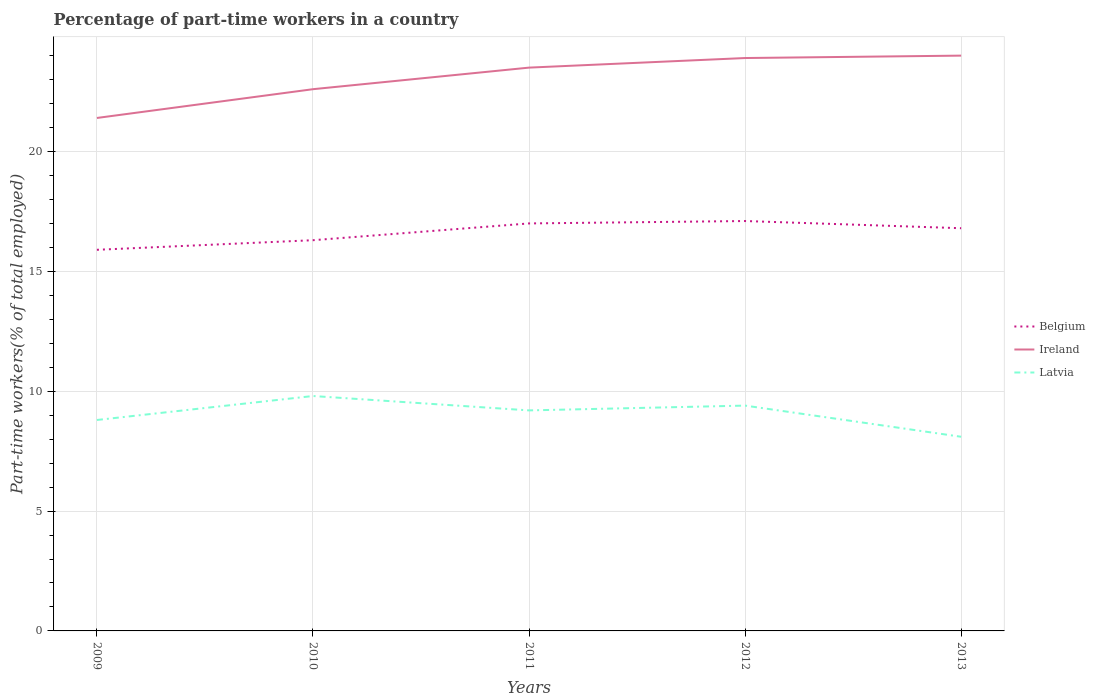Does the line corresponding to Latvia intersect with the line corresponding to Ireland?
Provide a succinct answer. No. Is the number of lines equal to the number of legend labels?
Offer a terse response. Yes. Across all years, what is the maximum percentage of part-time workers in Latvia?
Your response must be concise. 8.1. What is the total percentage of part-time workers in Belgium in the graph?
Offer a very short reply. 0.3. What is the difference between the highest and the second highest percentage of part-time workers in Ireland?
Your answer should be very brief. 2.6. How many lines are there?
Ensure brevity in your answer.  3. Are the values on the major ticks of Y-axis written in scientific E-notation?
Provide a short and direct response. No. Does the graph contain any zero values?
Make the answer very short. No. Does the graph contain grids?
Provide a short and direct response. Yes. Where does the legend appear in the graph?
Give a very brief answer. Center right. How are the legend labels stacked?
Ensure brevity in your answer.  Vertical. What is the title of the graph?
Your answer should be very brief. Percentage of part-time workers in a country. What is the label or title of the X-axis?
Offer a very short reply. Years. What is the label or title of the Y-axis?
Make the answer very short. Part-time workers(% of total employed). What is the Part-time workers(% of total employed) of Belgium in 2009?
Your response must be concise. 15.9. What is the Part-time workers(% of total employed) in Ireland in 2009?
Make the answer very short. 21.4. What is the Part-time workers(% of total employed) in Latvia in 2009?
Your response must be concise. 8.8. What is the Part-time workers(% of total employed) in Belgium in 2010?
Your answer should be compact. 16.3. What is the Part-time workers(% of total employed) in Ireland in 2010?
Give a very brief answer. 22.6. What is the Part-time workers(% of total employed) in Latvia in 2010?
Offer a terse response. 9.8. What is the Part-time workers(% of total employed) in Latvia in 2011?
Provide a succinct answer. 9.2. What is the Part-time workers(% of total employed) of Belgium in 2012?
Your response must be concise. 17.1. What is the Part-time workers(% of total employed) of Ireland in 2012?
Keep it short and to the point. 23.9. What is the Part-time workers(% of total employed) in Latvia in 2012?
Offer a very short reply. 9.4. What is the Part-time workers(% of total employed) of Belgium in 2013?
Your answer should be very brief. 16.8. What is the Part-time workers(% of total employed) in Latvia in 2013?
Offer a very short reply. 8.1. Across all years, what is the maximum Part-time workers(% of total employed) in Belgium?
Provide a short and direct response. 17.1. Across all years, what is the maximum Part-time workers(% of total employed) in Latvia?
Keep it short and to the point. 9.8. Across all years, what is the minimum Part-time workers(% of total employed) in Belgium?
Ensure brevity in your answer.  15.9. Across all years, what is the minimum Part-time workers(% of total employed) of Ireland?
Your answer should be very brief. 21.4. Across all years, what is the minimum Part-time workers(% of total employed) in Latvia?
Give a very brief answer. 8.1. What is the total Part-time workers(% of total employed) of Belgium in the graph?
Make the answer very short. 83.1. What is the total Part-time workers(% of total employed) of Ireland in the graph?
Ensure brevity in your answer.  115.4. What is the total Part-time workers(% of total employed) in Latvia in the graph?
Your answer should be compact. 45.3. What is the difference between the Part-time workers(% of total employed) in Belgium in 2009 and that in 2010?
Your response must be concise. -0.4. What is the difference between the Part-time workers(% of total employed) in Latvia in 2009 and that in 2010?
Your response must be concise. -1. What is the difference between the Part-time workers(% of total employed) of Latvia in 2009 and that in 2011?
Your answer should be compact. -0.4. What is the difference between the Part-time workers(% of total employed) in Latvia in 2009 and that in 2012?
Provide a short and direct response. -0.6. What is the difference between the Part-time workers(% of total employed) in Belgium in 2009 and that in 2013?
Keep it short and to the point. -0.9. What is the difference between the Part-time workers(% of total employed) in Latvia in 2009 and that in 2013?
Keep it short and to the point. 0.7. What is the difference between the Part-time workers(% of total employed) in Belgium in 2010 and that in 2011?
Ensure brevity in your answer.  -0.7. What is the difference between the Part-time workers(% of total employed) in Ireland in 2010 and that in 2011?
Ensure brevity in your answer.  -0.9. What is the difference between the Part-time workers(% of total employed) in Latvia in 2010 and that in 2011?
Your answer should be compact. 0.6. What is the difference between the Part-time workers(% of total employed) of Latvia in 2010 and that in 2012?
Ensure brevity in your answer.  0.4. What is the difference between the Part-time workers(% of total employed) in Latvia in 2010 and that in 2013?
Give a very brief answer. 1.7. What is the difference between the Part-time workers(% of total employed) of Belgium in 2011 and that in 2012?
Keep it short and to the point. -0.1. What is the difference between the Part-time workers(% of total employed) of Belgium in 2011 and that in 2013?
Your answer should be very brief. 0.2. What is the difference between the Part-time workers(% of total employed) of Ireland in 2011 and that in 2013?
Offer a terse response. -0.5. What is the difference between the Part-time workers(% of total employed) in Belgium in 2012 and that in 2013?
Offer a very short reply. 0.3. What is the difference between the Part-time workers(% of total employed) in Ireland in 2012 and that in 2013?
Make the answer very short. -0.1. What is the difference between the Part-time workers(% of total employed) in Belgium in 2009 and the Part-time workers(% of total employed) in Latvia in 2010?
Keep it short and to the point. 6.1. What is the difference between the Part-time workers(% of total employed) of Belgium in 2009 and the Part-time workers(% of total employed) of Latvia in 2011?
Make the answer very short. 6.7. What is the difference between the Part-time workers(% of total employed) in Belgium in 2009 and the Part-time workers(% of total employed) in Ireland in 2012?
Offer a very short reply. -8. What is the difference between the Part-time workers(% of total employed) in Ireland in 2009 and the Part-time workers(% of total employed) in Latvia in 2012?
Keep it short and to the point. 12. What is the difference between the Part-time workers(% of total employed) of Belgium in 2009 and the Part-time workers(% of total employed) of Ireland in 2013?
Your response must be concise. -8.1. What is the difference between the Part-time workers(% of total employed) in Belgium in 2009 and the Part-time workers(% of total employed) in Latvia in 2013?
Offer a terse response. 7.8. What is the difference between the Part-time workers(% of total employed) in Ireland in 2009 and the Part-time workers(% of total employed) in Latvia in 2013?
Keep it short and to the point. 13.3. What is the difference between the Part-time workers(% of total employed) in Belgium in 2010 and the Part-time workers(% of total employed) in Ireland in 2012?
Your answer should be very brief. -7.6. What is the difference between the Part-time workers(% of total employed) in Ireland in 2010 and the Part-time workers(% of total employed) in Latvia in 2012?
Your response must be concise. 13.2. What is the difference between the Part-time workers(% of total employed) of Belgium in 2010 and the Part-time workers(% of total employed) of Ireland in 2013?
Keep it short and to the point. -7.7. What is the difference between the Part-time workers(% of total employed) in Ireland in 2010 and the Part-time workers(% of total employed) in Latvia in 2013?
Provide a succinct answer. 14.5. What is the difference between the Part-time workers(% of total employed) in Belgium in 2011 and the Part-time workers(% of total employed) in Ireland in 2012?
Offer a terse response. -6.9. What is the difference between the Part-time workers(% of total employed) of Belgium in 2011 and the Part-time workers(% of total employed) of Latvia in 2012?
Your answer should be compact. 7.6. What is the difference between the Part-time workers(% of total employed) in Ireland in 2011 and the Part-time workers(% of total employed) in Latvia in 2012?
Ensure brevity in your answer.  14.1. What is the difference between the Part-time workers(% of total employed) of Belgium in 2011 and the Part-time workers(% of total employed) of Latvia in 2013?
Provide a short and direct response. 8.9. What is the difference between the Part-time workers(% of total employed) in Ireland in 2011 and the Part-time workers(% of total employed) in Latvia in 2013?
Offer a terse response. 15.4. What is the difference between the Part-time workers(% of total employed) in Belgium in 2012 and the Part-time workers(% of total employed) in Latvia in 2013?
Provide a succinct answer. 9. What is the difference between the Part-time workers(% of total employed) of Ireland in 2012 and the Part-time workers(% of total employed) of Latvia in 2013?
Your answer should be very brief. 15.8. What is the average Part-time workers(% of total employed) of Belgium per year?
Offer a very short reply. 16.62. What is the average Part-time workers(% of total employed) of Ireland per year?
Your response must be concise. 23.08. What is the average Part-time workers(% of total employed) in Latvia per year?
Give a very brief answer. 9.06. In the year 2009, what is the difference between the Part-time workers(% of total employed) in Belgium and Part-time workers(% of total employed) in Ireland?
Provide a succinct answer. -5.5. In the year 2009, what is the difference between the Part-time workers(% of total employed) of Ireland and Part-time workers(% of total employed) of Latvia?
Your answer should be very brief. 12.6. In the year 2010, what is the difference between the Part-time workers(% of total employed) of Belgium and Part-time workers(% of total employed) of Ireland?
Ensure brevity in your answer.  -6.3. In the year 2011, what is the difference between the Part-time workers(% of total employed) of Ireland and Part-time workers(% of total employed) of Latvia?
Your response must be concise. 14.3. In the year 2012, what is the difference between the Part-time workers(% of total employed) in Belgium and Part-time workers(% of total employed) in Ireland?
Keep it short and to the point. -6.8. In the year 2012, what is the difference between the Part-time workers(% of total employed) in Belgium and Part-time workers(% of total employed) in Latvia?
Your answer should be compact. 7.7. In the year 2013, what is the difference between the Part-time workers(% of total employed) of Belgium and Part-time workers(% of total employed) of Ireland?
Offer a very short reply. -7.2. In the year 2013, what is the difference between the Part-time workers(% of total employed) in Ireland and Part-time workers(% of total employed) in Latvia?
Offer a very short reply. 15.9. What is the ratio of the Part-time workers(% of total employed) in Belgium in 2009 to that in 2010?
Your response must be concise. 0.98. What is the ratio of the Part-time workers(% of total employed) in Ireland in 2009 to that in 2010?
Offer a terse response. 0.95. What is the ratio of the Part-time workers(% of total employed) of Latvia in 2009 to that in 2010?
Give a very brief answer. 0.9. What is the ratio of the Part-time workers(% of total employed) in Belgium in 2009 to that in 2011?
Your response must be concise. 0.94. What is the ratio of the Part-time workers(% of total employed) in Ireland in 2009 to that in 2011?
Give a very brief answer. 0.91. What is the ratio of the Part-time workers(% of total employed) of Latvia in 2009 to that in 2011?
Provide a succinct answer. 0.96. What is the ratio of the Part-time workers(% of total employed) in Belgium in 2009 to that in 2012?
Offer a terse response. 0.93. What is the ratio of the Part-time workers(% of total employed) in Ireland in 2009 to that in 2012?
Provide a succinct answer. 0.9. What is the ratio of the Part-time workers(% of total employed) in Latvia in 2009 to that in 2012?
Keep it short and to the point. 0.94. What is the ratio of the Part-time workers(% of total employed) of Belgium in 2009 to that in 2013?
Give a very brief answer. 0.95. What is the ratio of the Part-time workers(% of total employed) in Ireland in 2009 to that in 2013?
Offer a very short reply. 0.89. What is the ratio of the Part-time workers(% of total employed) in Latvia in 2009 to that in 2013?
Give a very brief answer. 1.09. What is the ratio of the Part-time workers(% of total employed) of Belgium in 2010 to that in 2011?
Your answer should be compact. 0.96. What is the ratio of the Part-time workers(% of total employed) of Ireland in 2010 to that in 2011?
Keep it short and to the point. 0.96. What is the ratio of the Part-time workers(% of total employed) in Latvia in 2010 to that in 2011?
Offer a terse response. 1.07. What is the ratio of the Part-time workers(% of total employed) in Belgium in 2010 to that in 2012?
Offer a very short reply. 0.95. What is the ratio of the Part-time workers(% of total employed) of Ireland in 2010 to that in 2012?
Offer a terse response. 0.95. What is the ratio of the Part-time workers(% of total employed) of Latvia in 2010 to that in 2012?
Provide a short and direct response. 1.04. What is the ratio of the Part-time workers(% of total employed) of Belgium in 2010 to that in 2013?
Offer a terse response. 0.97. What is the ratio of the Part-time workers(% of total employed) of Ireland in 2010 to that in 2013?
Make the answer very short. 0.94. What is the ratio of the Part-time workers(% of total employed) in Latvia in 2010 to that in 2013?
Give a very brief answer. 1.21. What is the ratio of the Part-time workers(% of total employed) of Belgium in 2011 to that in 2012?
Ensure brevity in your answer.  0.99. What is the ratio of the Part-time workers(% of total employed) of Ireland in 2011 to that in 2012?
Give a very brief answer. 0.98. What is the ratio of the Part-time workers(% of total employed) of Latvia in 2011 to that in 2012?
Provide a short and direct response. 0.98. What is the ratio of the Part-time workers(% of total employed) in Belgium in 2011 to that in 2013?
Ensure brevity in your answer.  1.01. What is the ratio of the Part-time workers(% of total employed) in Ireland in 2011 to that in 2013?
Provide a succinct answer. 0.98. What is the ratio of the Part-time workers(% of total employed) of Latvia in 2011 to that in 2013?
Your answer should be compact. 1.14. What is the ratio of the Part-time workers(% of total employed) of Belgium in 2012 to that in 2013?
Provide a short and direct response. 1.02. What is the ratio of the Part-time workers(% of total employed) in Ireland in 2012 to that in 2013?
Make the answer very short. 1. What is the ratio of the Part-time workers(% of total employed) of Latvia in 2012 to that in 2013?
Provide a succinct answer. 1.16. What is the difference between the highest and the second highest Part-time workers(% of total employed) in Belgium?
Ensure brevity in your answer.  0.1. What is the difference between the highest and the second highest Part-time workers(% of total employed) in Ireland?
Make the answer very short. 0.1. What is the difference between the highest and the second highest Part-time workers(% of total employed) in Latvia?
Your answer should be very brief. 0.4. What is the difference between the highest and the lowest Part-time workers(% of total employed) of Belgium?
Make the answer very short. 1.2. What is the difference between the highest and the lowest Part-time workers(% of total employed) of Ireland?
Offer a very short reply. 2.6. What is the difference between the highest and the lowest Part-time workers(% of total employed) of Latvia?
Your answer should be very brief. 1.7. 